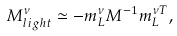Convert formula to latex. <formula><loc_0><loc_0><loc_500><loc_500>M _ { l i g h t } ^ { \nu } \simeq - m _ { L } ^ { \nu } M ^ { - 1 } m _ { L } ^ { \nu T } ,</formula> 